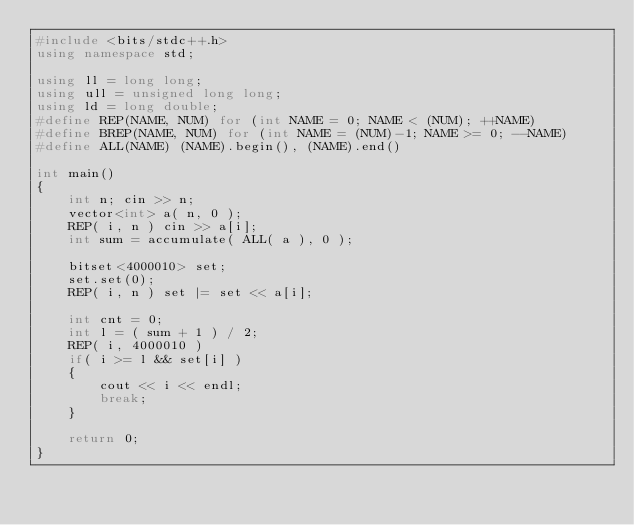Convert code to text. <code><loc_0><loc_0><loc_500><loc_500><_C++_>#include <bits/stdc++.h>
using namespace std;

using ll = long long;
using ull = unsigned long long;
using ld = long double;
#define REP(NAME, NUM) for (int NAME = 0; NAME < (NUM); ++NAME)
#define BREP(NAME, NUM) for (int NAME = (NUM)-1; NAME >= 0; --NAME)
#define ALL(NAME) (NAME).begin(), (NAME).end()

int main()
{
	int n; cin >> n;
	vector<int> a( n, 0 );
	REP( i, n ) cin >> a[i];
	int sum = accumulate( ALL( a ), 0 );

	bitset<4000010> set;
	set.set(0);
	REP( i, n ) set |= set << a[i];
	
	int cnt = 0;
	int l = ( sum + 1 ) / 2;
	REP( i, 4000010 )
	if( i >= l && set[i] )
	{
		cout << i << endl;
		break;
	}

	return 0;
}</code> 